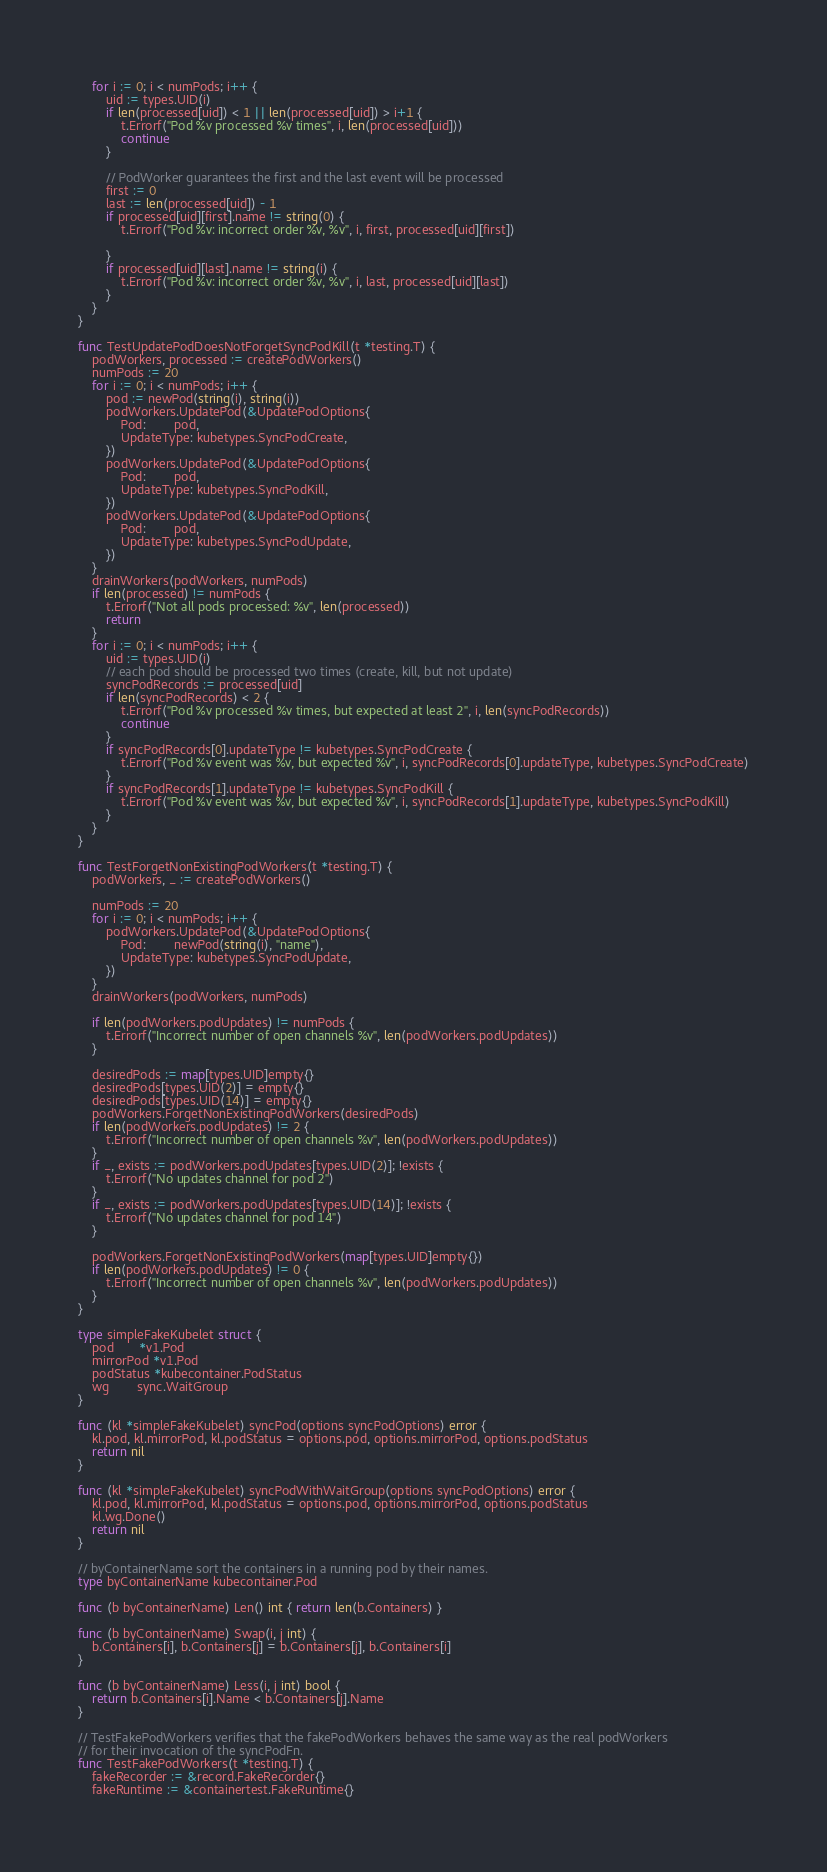<code> <loc_0><loc_0><loc_500><loc_500><_Go_>	for i := 0; i < numPods; i++ {
		uid := types.UID(i)
		if len(processed[uid]) < 1 || len(processed[uid]) > i+1 {
			t.Errorf("Pod %v processed %v times", i, len(processed[uid]))
			continue
		}

		// PodWorker guarantees the first and the last event will be processed
		first := 0
		last := len(processed[uid]) - 1
		if processed[uid][first].name != string(0) {
			t.Errorf("Pod %v: incorrect order %v, %v", i, first, processed[uid][first])

		}
		if processed[uid][last].name != string(i) {
			t.Errorf("Pod %v: incorrect order %v, %v", i, last, processed[uid][last])
		}
	}
}

func TestUpdatePodDoesNotForgetSyncPodKill(t *testing.T) {
	podWorkers, processed := createPodWorkers()
	numPods := 20
	for i := 0; i < numPods; i++ {
		pod := newPod(string(i), string(i))
		podWorkers.UpdatePod(&UpdatePodOptions{
			Pod:        pod,
			UpdateType: kubetypes.SyncPodCreate,
		})
		podWorkers.UpdatePod(&UpdatePodOptions{
			Pod:        pod,
			UpdateType: kubetypes.SyncPodKill,
		})
		podWorkers.UpdatePod(&UpdatePodOptions{
			Pod:        pod,
			UpdateType: kubetypes.SyncPodUpdate,
		})
	}
	drainWorkers(podWorkers, numPods)
	if len(processed) != numPods {
		t.Errorf("Not all pods processed: %v", len(processed))
		return
	}
	for i := 0; i < numPods; i++ {
		uid := types.UID(i)
		// each pod should be processed two times (create, kill, but not update)
		syncPodRecords := processed[uid]
		if len(syncPodRecords) < 2 {
			t.Errorf("Pod %v processed %v times, but expected at least 2", i, len(syncPodRecords))
			continue
		}
		if syncPodRecords[0].updateType != kubetypes.SyncPodCreate {
			t.Errorf("Pod %v event was %v, but expected %v", i, syncPodRecords[0].updateType, kubetypes.SyncPodCreate)
		}
		if syncPodRecords[1].updateType != kubetypes.SyncPodKill {
			t.Errorf("Pod %v event was %v, but expected %v", i, syncPodRecords[1].updateType, kubetypes.SyncPodKill)
		}
	}
}

func TestForgetNonExistingPodWorkers(t *testing.T) {
	podWorkers, _ := createPodWorkers()

	numPods := 20
	for i := 0; i < numPods; i++ {
		podWorkers.UpdatePod(&UpdatePodOptions{
			Pod:        newPod(string(i), "name"),
			UpdateType: kubetypes.SyncPodUpdate,
		})
	}
	drainWorkers(podWorkers, numPods)

	if len(podWorkers.podUpdates) != numPods {
		t.Errorf("Incorrect number of open channels %v", len(podWorkers.podUpdates))
	}

	desiredPods := map[types.UID]empty{}
	desiredPods[types.UID(2)] = empty{}
	desiredPods[types.UID(14)] = empty{}
	podWorkers.ForgetNonExistingPodWorkers(desiredPods)
	if len(podWorkers.podUpdates) != 2 {
		t.Errorf("Incorrect number of open channels %v", len(podWorkers.podUpdates))
	}
	if _, exists := podWorkers.podUpdates[types.UID(2)]; !exists {
		t.Errorf("No updates channel for pod 2")
	}
	if _, exists := podWorkers.podUpdates[types.UID(14)]; !exists {
		t.Errorf("No updates channel for pod 14")
	}

	podWorkers.ForgetNonExistingPodWorkers(map[types.UID]empty{})
	if len(podWorkers.podUpdates) != 0 {
		t.Errorf("Incorrect number of open channels %v", len(podWorkers.podUpdates))
	}
}

type simpleFakeKubelet struct {
	pod       *v1.Pod
	mirrorPod *v1.Pod
	podStatus *kubecontainer.PodStatus
	wg        sync.WaitGroup
}

func (kl *simpleFakeKubelet) syncPod(options syncPodOptions) error {
	kl.pod, kl.mirrorPod, kl.podStatus = options.pod, options.mirrorPod, options.podStatus
	return nil
}

func (kl *simpleFakeKubelet) syncPodWithWaitGroup(options syncPodOptions) error {
	kl.pod, kl.mirrorPod, kl.podStatus = options.pod, options.mirrorPod, options.podStatus
	kl.wg.Done()
	return nil
}

// byContainerName sort the containers in a running pod by their names.
type byContainerName kubecontainer.Pod

func (b byContainerName) Len() int { return len(b.Containers) }

func (b byContainerName) Swap(i, j int) {
	b.Containers[i], b.Containers[j] = b.Containers[j], b.Containers[i]
}

func (b byContainerName) Less(i, j int) bool {
	return b.Containers[i].Name < b.Containers[j].Name
}

// TestFakePodWorkers verifies that the fakePodWorkers behaves the same way as the real podWorkers
// for their invocation of the syncPodFn.
func TestFakePodWorkers(t *testing.T) {
	fakeRecorder := &record.FakeRecorder{}
	fakeRuntime := &containertest.FakeRuntime{}</code> 